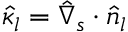<formula> <loc_0><loc_0><loc_500><loc_500>\hat { \kappa } _ { l } = \hat { \nabla } _ { s } \cdot \hat { n } _ { l }</formula> 